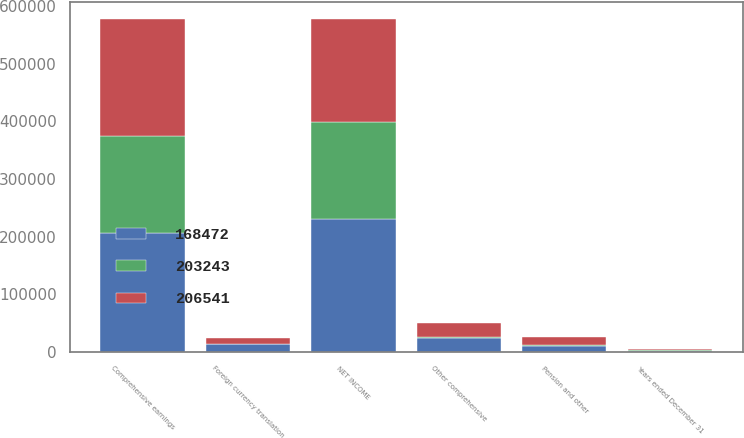Convert chart. <chart><loc_0><loc_0><loc_500><loc_500><stacked_bar_chart><ecel><fcel>Years ended December 31<fcel>NET INCOME<fcel>Pension and other<fcel>Foreign currency translation<fcel>Other comprehensive<fcel>Comprehensive earnings<nl><fcel>168472<fcel>2018<fcel>231663<fcel>11050<fcel>14072<fcel>25122<fcel>206541<nl><fcel>206541<fcel>2017<fcel>179124<fcel>14159<fcel>9960<fcel>24119<fcel>203243<nl><fcel>203243<fcel>2016<fcel>167369<fcel>1705<fcel>602<fcel>1103<fcel>168472<nl></chart> 